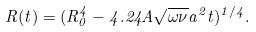<formula> <loc_0><loc_0><loc_500><loc_500>R ( t ) = ( R _ { 0 } ^ { 4 } - 4 . 2 4 A \sqrt { \omega \nu } a ^ { 2 } t ) ^ { 1 / 4 } .</formula> 